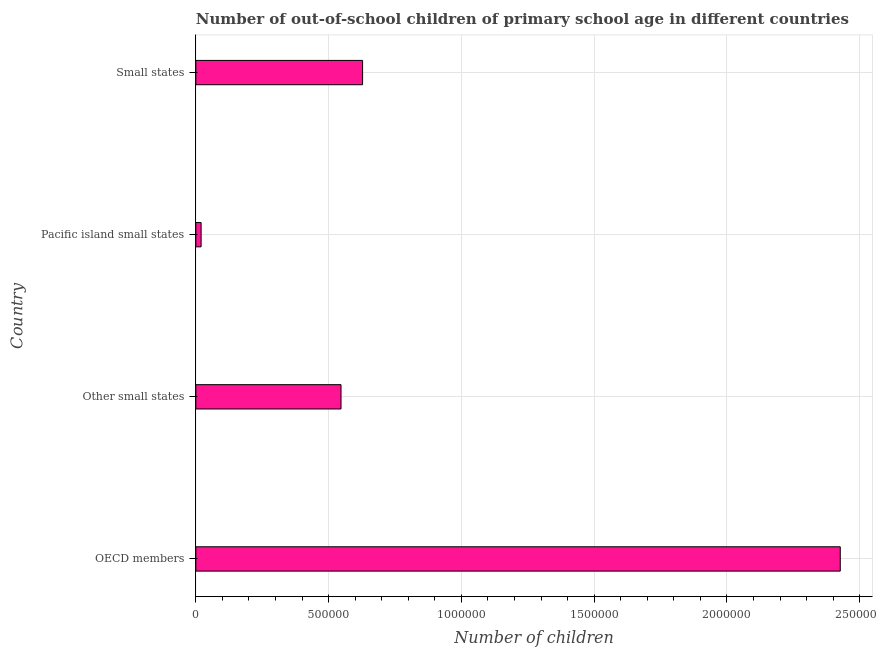What is the title of the graph?
Offer a terse response. Number of out-of-school children of primary school age in different countries. What is the label or title of the X-axis?
Your response must be concise. Number of children. What is the number of out-of-school children in Small states?
Provide a succinct answer. 6.28e+05. Across all countries, what is the maximum number of out-of-school children?
Offer a very short reply. 2.43e+06. Across all countries, what is the minimum number of out-of-school children?
Offer a terse response. 1.99e+04. In which country was the number of out-of-school children maximum?
Offer a terse response. OECD members. In which country was the number of out-of-school children minimum?
Provide a succinct answer. Pacific island small states. What is the sum of the number of out-of-school children?
Provide a succinct answer. 3.62e+06. What is the difference between the number of out-of-school children in OECD members and Pacific island small states?
Keep it short and to the point. 2.41e+06. What is the average number of out-of-school children per country?
Give a very brief answer. 9.05e+05. What is the median number of out-of-school children?
Keep it short and to the point. 5.87e+05. What is the ratio of the number of out-of-school children in Other small states to that in Pacific island small states?
Your response must be concise. 27.48. What is the difference between the highest and the second highest number of out-of-school children?
Give a very brief answer. 1.80e+06. What is the difference between the highest and the lowest number of out-of-school children?
Your answer should be compact. 2.41e+06. In how many countries, is the number of out-of-school children greater than the average number of out-of-school children taken over all countries?
Your answer should be very brief. 1. Are all the bars in the graph horizontal?
Your response must be concise. Yes. What is the difference between two consecutive major ticks on the X-axis?
Your answer should be very brief. 5.00e+05. What is the Number of children of OECD members?
Provide a succinct answer. 2.43e+06. What is the Number of children in Other small states?
Give a very brief answer. 5.47e+05. What is the Number of children of Pacific island small states?
Offer a very short reply. 1.99e+04. What is the Number of children of Small states?
Give a very brief answer. 6.28e+05. What is the difference between the Number of children in OECD members and Other small states?
Provide a short and direct response. 1.88e+06. What is the difference between the Number of children in OECD members and Pacific island small states?
Offer a terse response. 2.41e+06. What is the difference between the Number of children in OECD members and Small states?
Your answer should be compact. 1.80e+06. What is the difference between the Number of children in Other small states and Pacific island small states?
Offer a very short reply. 5.27e+05. What is the difference between the Number of children in Other small states and Small states?
Give a very brief answer. -8.12e+04. What is the difference between the Number of children in Pacific island small states and Small states?
Ensure brevity in your answer.  -6.08e+05. What is the ratio of the Number of children in OECD members to that in Other small states?
Ensure brevity in your answer.  4.44. What is the ratio of the Number of children in OECD members to that in Pacific island small states?
Provide a succinct answer. 121.98. What is the ratio of the Number of children in OECD members to that in Small states?
Your response must be concise. 3.86. What is the ratio of the Number of children in Other small states to that in Pacific island small states?
Ensure brevity in your answer.  27.48. What is the ratio of the Number of children in Other small states to that in Small states?
Your response must be concise. 0.87. What is the ratio of the Number of children in Pacific island small states to that in Small states?
Provide a succinct answer. 0.03. 